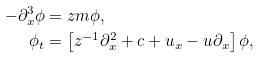<formula> <loc_0><loc_0><loc_500><loc_500>- \partial _ { x } ^ { 3 } \phi & = z m \phi , \\ \phi _ { t } & = \left [ z ^ { - 1 } \partial _ { x } ^ { 2 } + c + u _ { x } - u \partial _ { x } \right ] \phi ,</formula> 